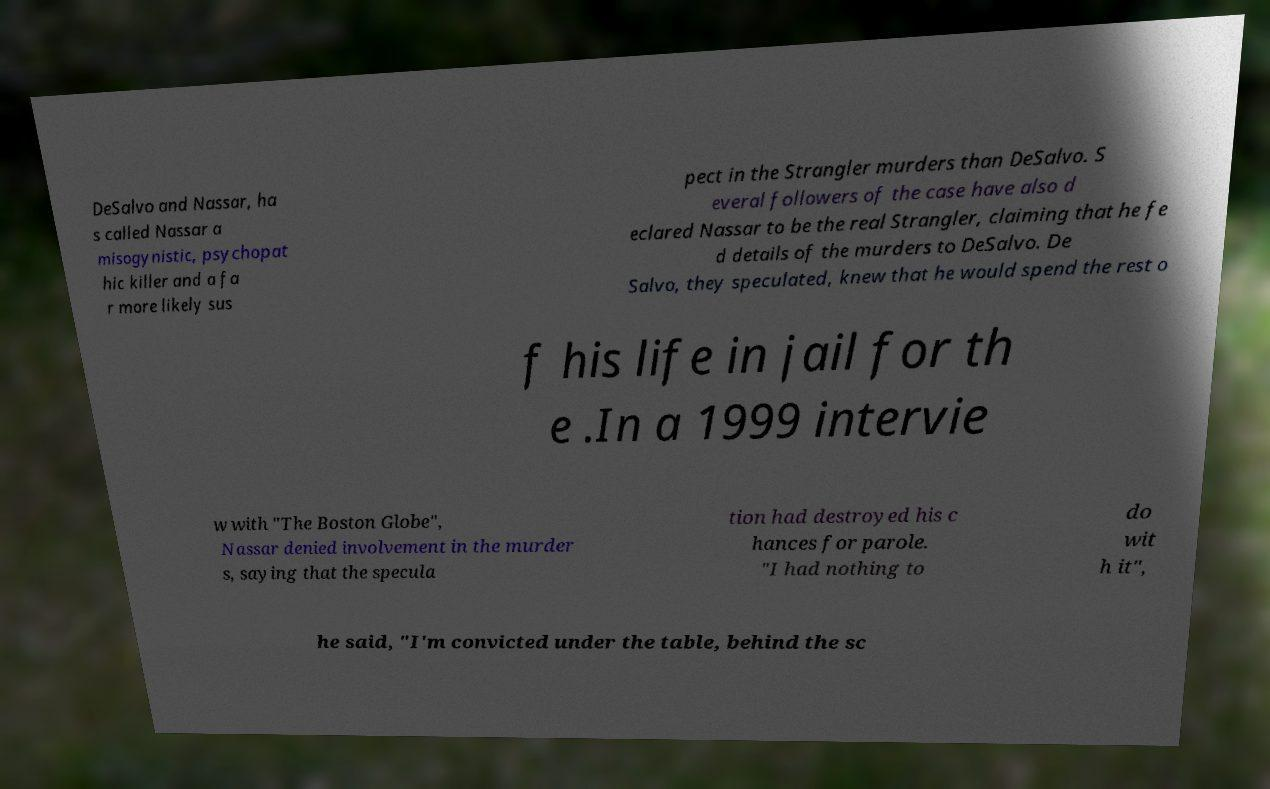Could you assist in decoding the text presented in this image and type it out clearly? DeSalvo and Nassar, ha s called Nassar a misogynistic, psychopat hic killer and a fa r more likely sus pect in the Strangler murders than DeSalvo. S everal followers of the case have also d eclared Nassar to be the real Strangler, claiming that he fe d details of the murders to DeSalvo. De Salvo, they speculated, knew that he would spend the rest o f his life in jail for th e .In a 1999 intervie w with "The Boston Globe", Nassar denied involvement in the murder s, saying that the specula tion had destroyed his c hances for parole. "I had nothing to do wit h it", he said, "I'm convicted under the table, behind the sc 